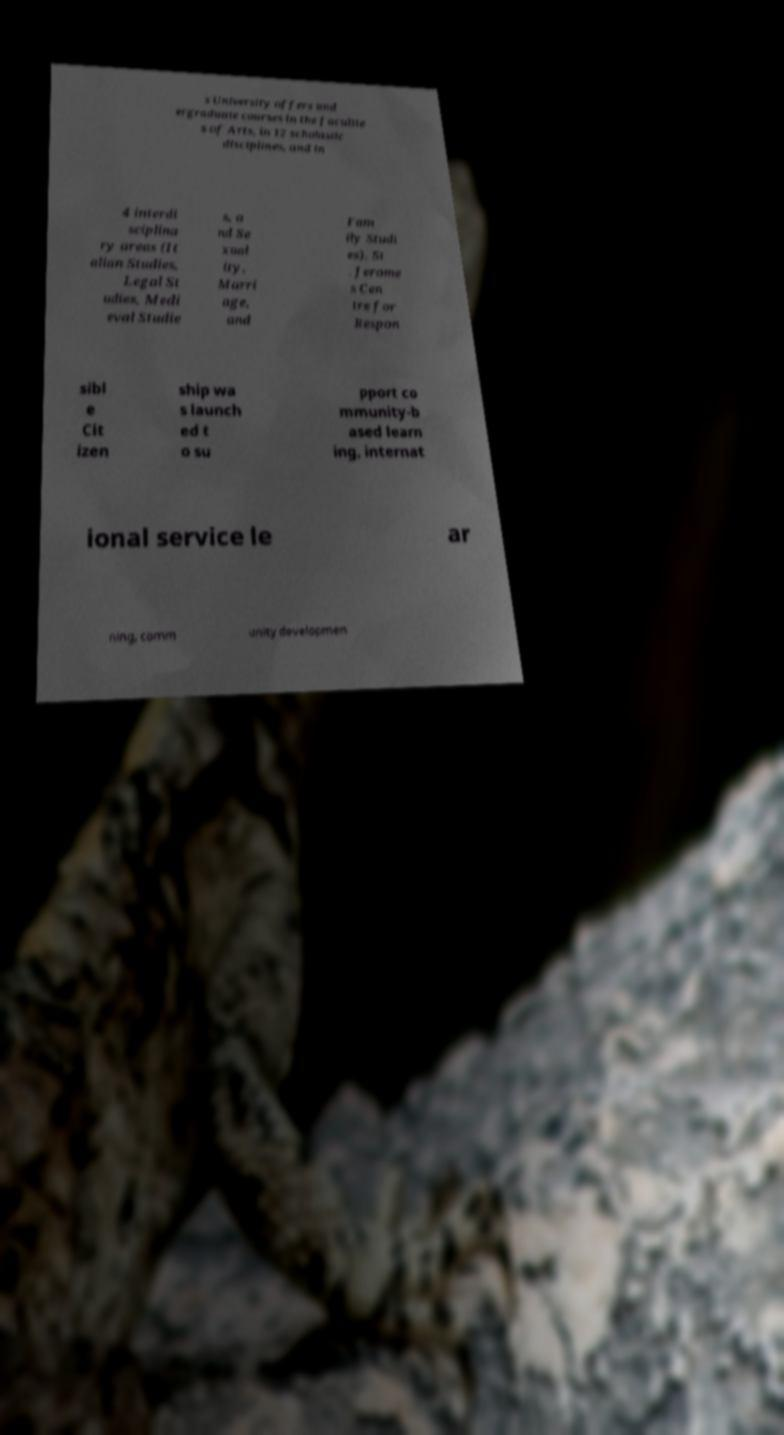Please identify and transcribe the text found in this image. s University offers und ergraduate courses in the facultie s of Arts, in 12 scholastic disciplines, and in 4 interdi sciplina ry areas (It alian Studies, Legal St udies, Medi eval Studie s, a nd Se xual ity, Marri age, and Fam ily Studi es). St . Jerome s Cen tre for Respon sibl e Cit izen ship wa s launch ed t o su pport co mmunity-b ased learn ing, internat ional service le ar ning, comm unity developmen 